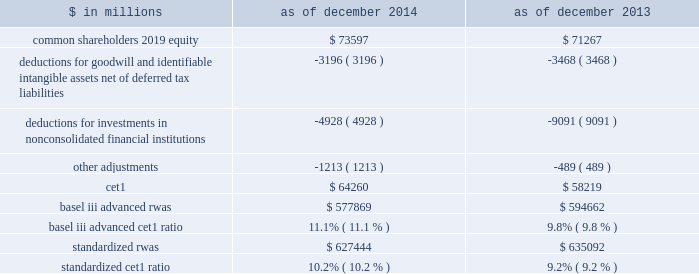Management 2019s discussion and analysis fully phased-in capital ratios the table below presents our estimated ratio of cet1 to rwas calculated under the basel iii advanced rules and the standardized capital rules on a fully phased-in basis. .
Although the fully phased-in capital ratios are not applicable until 2019 , we believe that the estimated ratios in the table above are meaningful because they are measures that we , our regulators and investors use to assess our ability to meet future regulatory capital requirements .
The estimated fully phased-in basel iii advanced and standardized cet1 ratios are non-gaap measures as of both december 2014 and december 2013 and may not be comparable to similar non-gaap measures used by other companies ( as of those dates ) .
These estimated ratios are based on our current interpretation , expectations and understanding of the revised capital framework and may evolve as we discuss its interpretation and application with our regulators .
See note 20 to the consolidated financial statements for information about our transitional capital ratios , which represent our binding ratios as of december 2014 .
In the table above : 2030 the deduction for goodwill and identifiable intangible assets , net of deferred tax liabilities , represents goodwill of $ 3.65 billion and $ 3.71 billion as of december 2014 and december 2013 , respectively , and identifiable intangible assets of $ 515 million and $ 671 million as of december 2014 and december 2013 , respectively , net of associated deferred tax liabilities of $ 964 million and $ 908 million as of december 2014 and december 2013 , respectively .
2030 the deduction for investments in nonconsolidated financial institutions represents the amount by which our investments in the capital of nonconsolidated financial institutions exceed certain prescribed thresholds .
The decrease from december 2013 to december 2014 primarily reflects reductions in our fund investments .
2030 other adjustments primarily include the overfunded portion of our defined benefit pension plan obligation , net of associated deferred tax liabilities , and disallowed deferred tax assets , credit valuation adjustments on derivative liabilities and debt valuation adjustments , as well as other required credit risk-based deductions .
Supplementary leverage ratio the revised capital framework introduces a new supplementary leverage ratio for advanced approach banking organizations .
Under amendments to the revised capital framework , the u.s .
Federal bank regulatory agencies approved a final rule that implements the supplementary leverage ratio aligned with the definition of leverage established by the basel committee .
The supplementary leverage ratio compares tier 1 capital to a measure of leverage exposure , defined as the sum of our quarterly average assets less certain deductions plus certain off-balance-sheet exposures , including a measure of derivatives exposures and commitments .
The revised capital framework requires a minimum supplementary leverage ratio of 5.0% ( 5.0 % ) ( comprised of the minimum requirement of 3.0% ( 3.0 % ) and a 2.0% ( 2.0 % ) buffer ) for u.s .
Banks deemed to be g-sibs , effective on january 1 , 2018 .
Certain disclosures regarding the supplementary leverage ratio are required beginning in the first quarter of 2015 .
As of december 2014 , our estimated supplementary leverage ratio was 5.0% ( 5.0 % ) , including tier 1 capital on a fully phased-in basis of $ 73.17 billion ( cet1 of $ 64.26 billion plus perpetual non-cumulative preferred stock of $ 9.20 billion less other adjustments of $ 290 million ) divided by total leverage exposure of $ 1.45 trillion ( total quarterly average assets of $ 873 billion plus adjustments of $ 579 billion , primarily comprised of off-balance-sheet exposure related to derivatives and commitments ) .
We believe that the estimated supplementary leverage ratio is meaningful because it is a measure that we , our regulators and investors use to assess our ability to meet future regulatory capital requirements .
The supplementary leverage ratio is a non-gaap measure and may not be comparable to similar non-gaap measures used by other companies .
This estimated supplementary leverage ratio is based on our current interpretation and understanding of the u.s .
Federal bank regulatory agencies 2019 final rule and may evolve as we discuss its interpretation and application with our regulators .
60 goldman sachs 2014 annual report .
What is the percentage change in standardized rwas in 2014? 
Computations: ((627444 - 635092) / 635092)
Answer: -0.01204. 